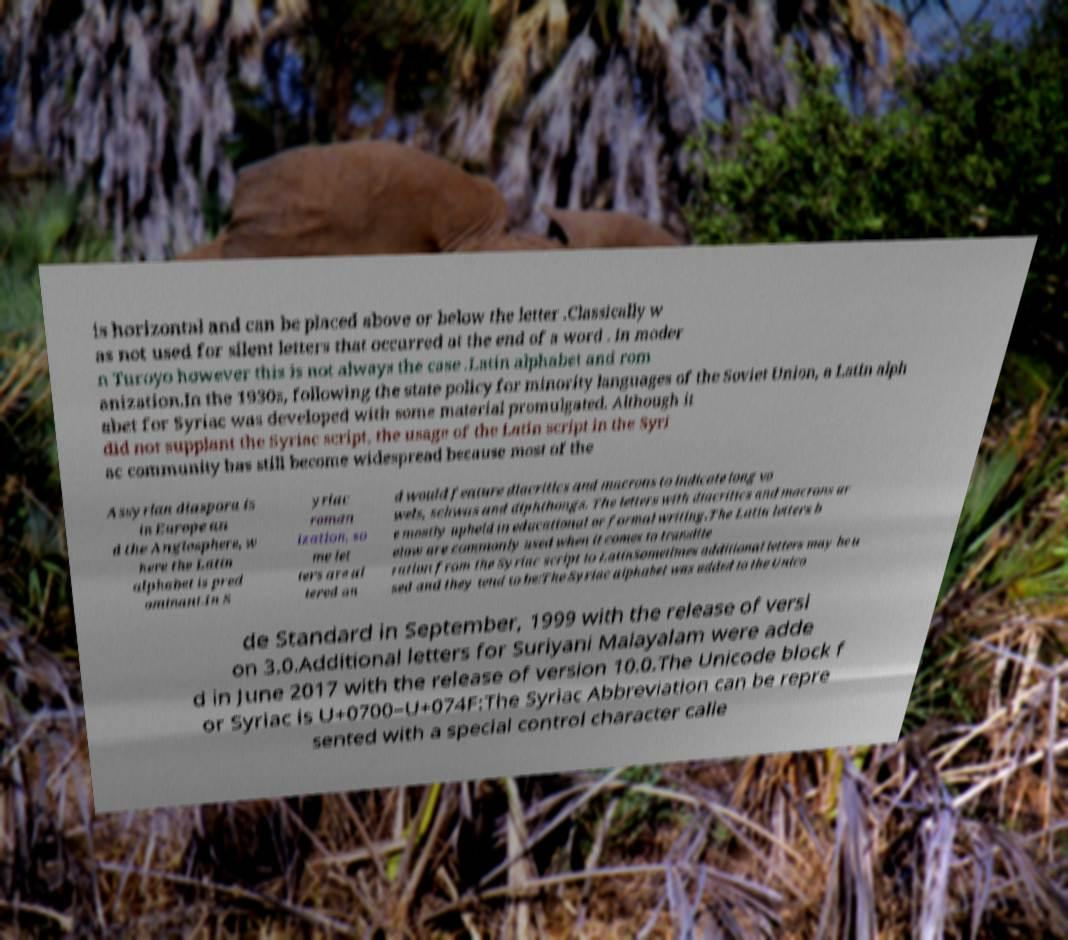For documentation purposes, I need the text within this image transcribed. Could you provide that? is horizontal and can be placed above or below the letter .Classically w as not used for silent letters that occurred at the end of a word . In moder n Turoyo however this is not always the case .Latin alphabet and rom anization.In the 1930s, following the state policy for minority languages of the Soviet Union, a Latin alph abet for Syriac was developed with some material promulgated. Although it did not supplant the Syriac script, the usage of the Latin script in the Syri ac community has still become widespread because most of the Assyrian diaspora is in Europe an d the Anglosphere, w here the Latin alphabet is pred ominant.In S yriac roman ization, so me let ters are al tered an d would feature diacritics and macrons to indicate long vo wels, schwas and diphthongs. The letters with diacritics and macrons ar e mostly upheld in educational or formal writing.The Latin letters b elow are commonly used when it comes to translite ration from the Syriac script to LatinSometimes additional letters may be u sed and they tend to be:The Syriac alphabet was added to the Unico de Standard in September, 1999 with the release of versi on 3.0.Additional letters for Suriyani Malayalam were adde d in June 2017 with the release of version 10.0.The Unicode block f or Syriac is U+0700–U+074F:The Syriac Abbreviation can be repre sented with a special control character calle 